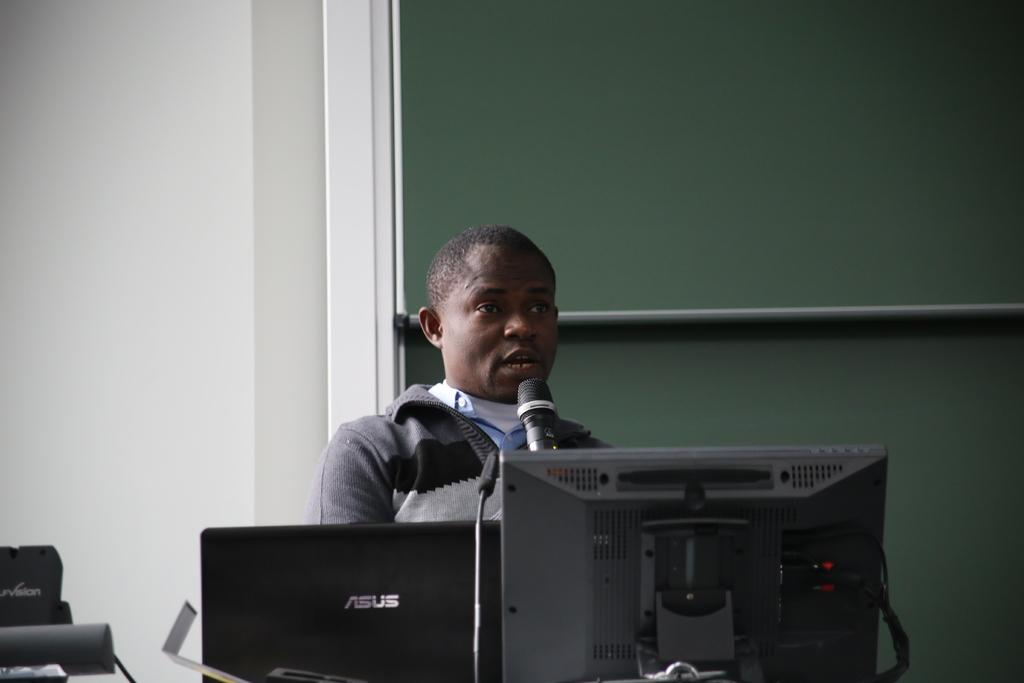What electronic devices can be seen in the image? There are monitors in the image. What device is used for amplifying sound or recording audio? There is a microphone (mic) in the image. What other objects are present in the image besides the monitors and mic? There are other objects in the image, but their specific details are not mentioned in the provided facts. Can you describe the background of the image? In the background of the image, there is a person, a board, and a wall. What type of badge is the person wearing on their feet in the image? There is no person wearing a badge on their feet in the image. What type of market can be seen in the background of the image? There is no market present in the image; it features monitors, a mic, and a background with a person, a board, and a wall. 